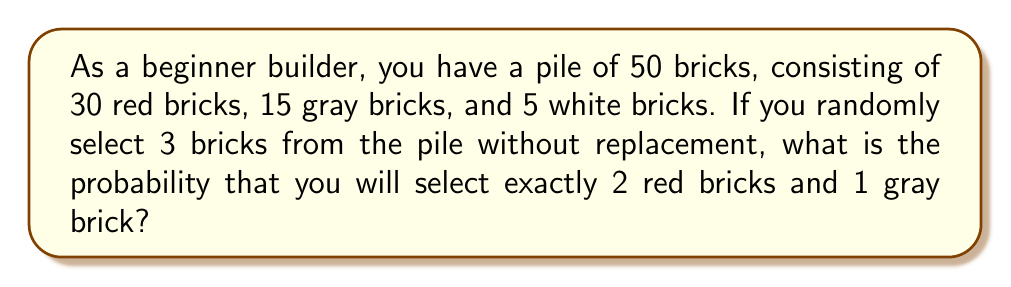Show me your answer to this math problem. Let's approach this step-by-step:

1) First, we need to calculate the total number of ways to select 3 bricks out of 50. This is given by the combination formula:

   $$\binom{50}{3} = \frac{50!}{3!(50-3)!} = \frac{50!}{3!47!} = 19,600$$

2) Now, we need to calculate the number of ways to select 2 red bricks and 1 gray brick:

   a) Select 2 red bricks out of 30: $$\binom{30}{2} = \frac{30!}{2!28!} = 435$$
   
   b) Select 1 gray brick out of 15: $$\binom{15}{1} = 15$$

3) The total number of favorable outcomes is the product of these:

   $$435 \times 15 = 6,525$$

4) The probability is then the number of favorable outcomes divided by the total number of possible outcomes:

   $$P(\text{2 red, 1 gray}) = \frac{6,525}{19,600}$$

5) Simplifying this fraction:

   $$\frac{6,525}{19,600} = \frac{1,305}{3,920} \approx 0.3329$$

Therefore, the probability of selecting exactly 2 red bricks and 1 gray brick is $\frac{1,305}{3,920}$ or approximately 0.3329 or 33.29%.
Answer: $\frac{1,305}{3,920}$ or approximately 0.3329 (33.29%) 